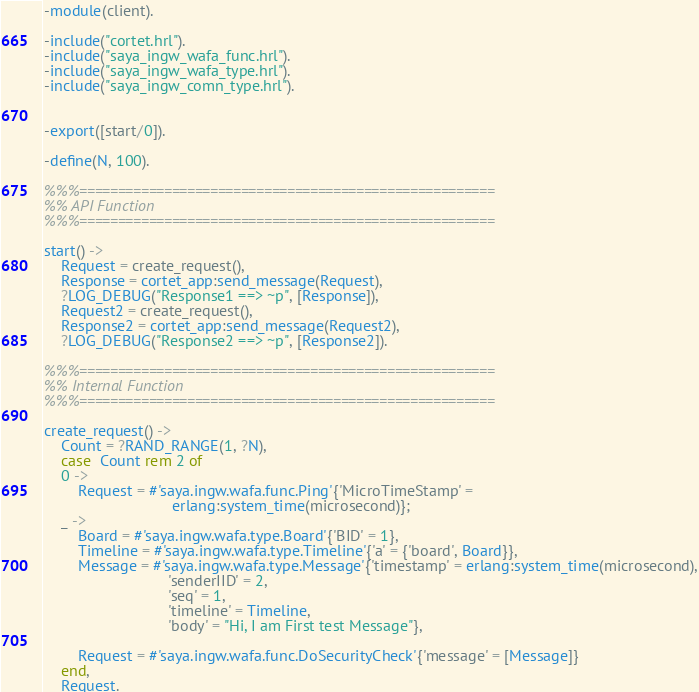<code> <loc_0><loc_0><loc_500><loc_500><_Erlang_>-module(client).

-include("cortet.hrl").
-include("saya_ingw_wafa_func.hrl").
-include("saya_ingw_wafa_type.hrl").
-include("saya_ingw_comn_type.hrl").


-export([start/0]).

-define(N, 100).

%%%======================================================
%% API Function
%%%======================================================

start() ->
    Request = create_request(),
    Response = cortet_app:send_message(Request),
    ?LOG_DEBUG("Response1 ==> ~p", [Response]),
    Request2 = create_request(),
    Response2 = cortet_app:send_message(Request2),
    ?LOG_DEBUG("Response2 ==> ~p", [Response2]).
    
%%%======================================================
%% Internal Function
%%%======================================================

create_request() ->
    Count = ?RAND_RANGE(1, ?N),
    case  Count rem 2 of
	0 ->
	    Request = #'saya.ingw.wafa.func.Ping'{'MicroTimeStamp' = 
						      erlang:system_time(microsecond)};
	_ ->
	    Board = #'saya.ingw.wafa.type.Board'{'BID' = 1},
	    Timeline = #'saya.ingw.wafa.type.Timeline'{'a' = {'board', Board}},
	    Message = #'saya.ingw.wafa.type.Message'{'timestamp' = erlang:system_time(microsecond),
						     'senderIID' = 2,
						     'seq' = 1,
						     'timeline' = Timeline,
						     'body' = "Hi, I am First test Message"},
	    
	    Request = #'saya.ingw.wafa.func.DoSecurityCheck'{'message' = [Message]}
    end,
    Request.
</code> 